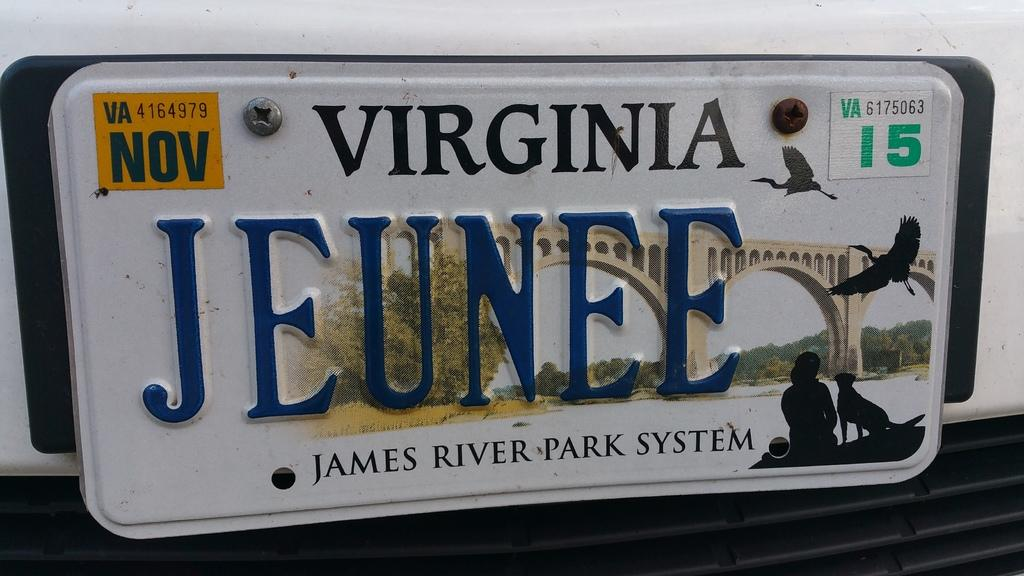<image>
Relay a brief, clear account of the picture shown. A Virginia vanity license plate says JEUNEE on it. 